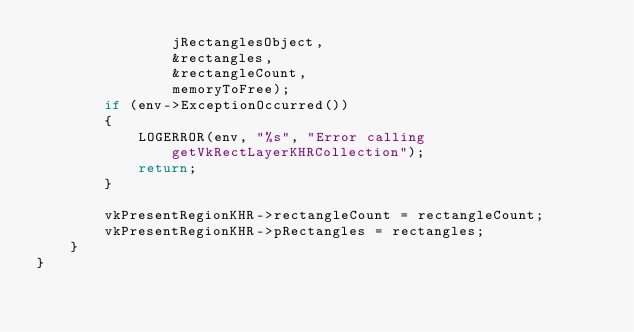<code> <loc_0><loc_0><loc_500><loc_500><_C++_>				jRectanglesObject,
                &rectangles,
                &rectangleCount,
                memoryToFree);
        if (env->ExceptionOccurred())
        {
        	LOGERROR(env, "%s", "Error calling getVkRectLayerKHRCollection");
            return;
        }

        vkPresentRegionKHR->rectangleCount = rectangleCount;
        vkPresentRegionKHR->pRectangles = rectangles;
    }
}
</code> 